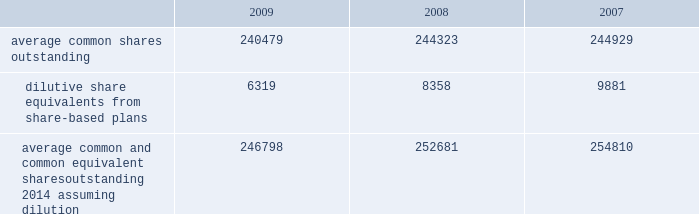The company has a restricted stock plan for non-employee directors which reserves for issuance of 300000 shares of the company 2019s common stock .
No restricted shares were issued in 2009 .
The company has a directors 2019 deferral plan , which provides a means to defer director compensation , from time to time , on a deferred stock or cash basis .
As of september 30 , 2009 , 86643 shares were held in trust , of which 4356 shares represented directors 2019 compensation in 2009 , in accordance with the provisions of the plan .
Under this plan , which is unfunded , directors have an unsecured contractual commitment from the company .
The company also has a deferred compensation plan that allows certain highly-compensated employees , including executive officers , to defer salary , annual incentive awards and certain equity-based compensation .
As of september 30 , 2009 , 557235 shares were issuable under this plan .
Note 16 2014 earnings per share the weighted average common shares used in the computations of basic and diluted earnings per share ( shares in thousands ) for the years ended september 30 were as follows: .
Average common and common equivalent shares outstanding 2014 assuming dilution .
246798 252681 254810 note 17 2014 segment data the company 2019s organizational structure is based upon its three principal business segments : bd medical ( 201cmedical 201d ) , bd diagnostics ( 201cdiagnostics 201d ) and bd biosciences ( 201cbiosciences 201d ) .
The principal product lines in the medical segment include needles , syringes and intravenous catheters for medication delivery ; safety-engineered and auto-disable devices ; prefilled iv flush syringes ; syringes and pen needles for the self-injection of insulin and other drugs used in the treatment of diabetes ; prefillable drug delivery devices provided to pharmaceutical companies and sold to end-users as drug/device combinations ; surgical blades/scalpels and regional anesthesia needles and trays ; critical care monitoring devices ; ophthalmic surgical instruments ; and sharps disposal containers .
The principal products and services in the diagnostics segment include integrated systems for specimen collection ; an extensive line of safety-engineered specimen blood collection products and systems ; plated media ; automated blood culturing systems ; molecular testing systems for sexually transmitted diseases and healthcare-associated infections ; microorganism identification and drug susceptibility systems ; liquid-based cytology systems for cervical cancer screening ; and rapid diagnostic assays .
The principal product lines in the biosciences segment include fluorescence activated cell sorters and analyzers ; cell imaging systems ; monoclonal antibodies and kits for performing cell analysis ; reagent systems for life sciences research ; tools to aid in drug discovery and growth of tissue and cells ; cell culture media supplements for biopharmaceutical manufacturing ; and diagnostic assays .
The company evaluates performance of its business segments based upon operating income .
Segment operating income represents revenues reduced by product costs and operating expenses .
The company hedges against certain forecasted sales of u.s.-produced products sold outside the united states .
Gains and losses associated with these foreign currency translation hedges are reported in segment revenues based upon their proportionate share of these international sales of u.s.-produced products .
Becton , dickinson and company notes to consolidated financial statements 2014 ( continued ) .
What is the percentage decrease for average common shares outstanding from 2008-2009? 
Computations: ((244323 - 240479) / 244323)
Answer: 0.01573. 